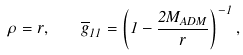<formula> <loc_0><loc_0><loc_500><loc_500>\rho = r , \text { } \text { } \text { } \text { } \overline { g } _ { 1 1 } = \left ( 1 - \frac { 2 M _ { A D M } } { r } \right ) ^ { - 1 } ,</formula> 